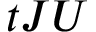Convert formula to latex. <formula><loc_0><loc_0><loc_500><loc_500>t J U</formula> 